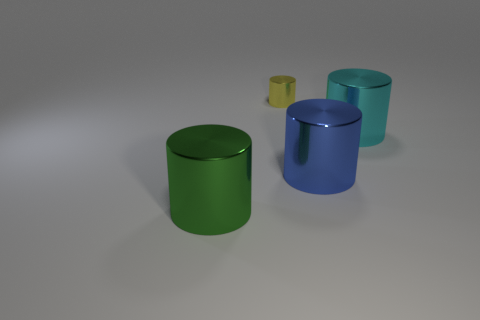How many objects are large things to the left of the cyan metallic cylinder or yellow things?
Your response must be concise. 3. There is a metal object that is on the left side of the metal thing behind the cylinder to the right of the blue cylinder; what color is it?
Offer a very short reply. Green. The other small thing that is the same material as the green object is what color?
Offer a very short reply. Yellow. What number of yellow objects have the same material as the cyan object?
Give a very brief answer. 1. Do the thing left of the yellow metallic thing and the big blue cylinder have the same size?
Keep it short and to the point. Yes. There is a big green metal cylinder; what number of large metal things are on the right side of it?
Provide a succinct answer. 2. Is there a large cyan metal object?
Your response must be concise. Yes. There is a blue thing that is in front of the thing behind the cyan object that is on the right side of the big blue metallic cylinder; what is its size?
Your answer should be compact. Large. How many other objects are the same size as the green object?
Give a very brief answer. 2. There is a shiny thing in front of the large blue cylinder; how big is it?
Offer a terse response. Large. 